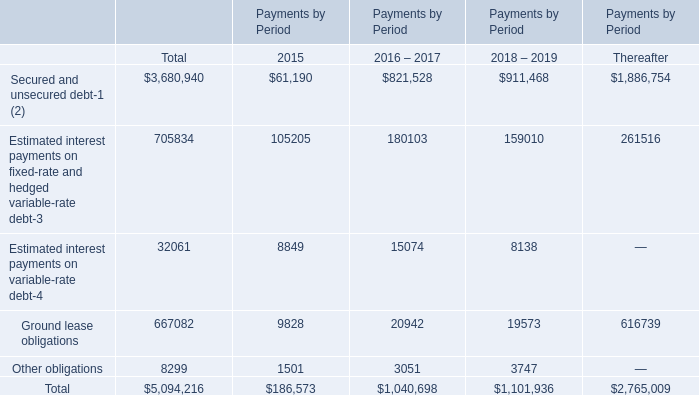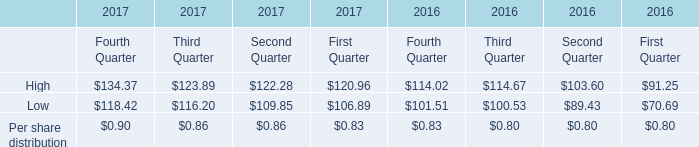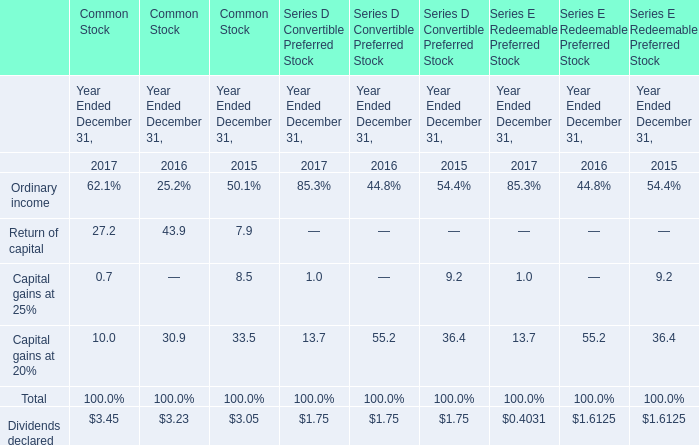What's the average of the Return of capital for Common Stock in the years where High for Fourth Quarter is positive? 
Computations: ((27.2 + 43.9) / 2)
Answer: 35.55. 